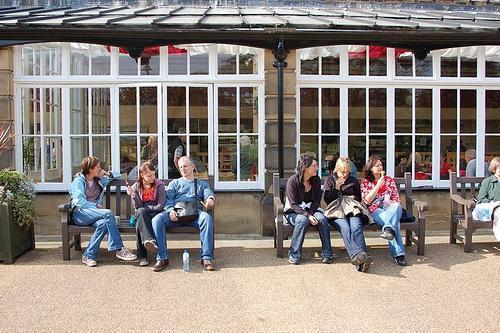How many people are sitting on the first bench to the left?
Give a very brief answer. 3. How many of the people have their legs/feet crossed?
Give a very brief answer. 4. How many benches are visible?
Give a very brief answer. 3. How many benches are in the picture?
Give a very brief answer. 3. How many potted plants are there?
Give a very brief answer. 1. How many people are there?
Give a very brief answer. 6. 